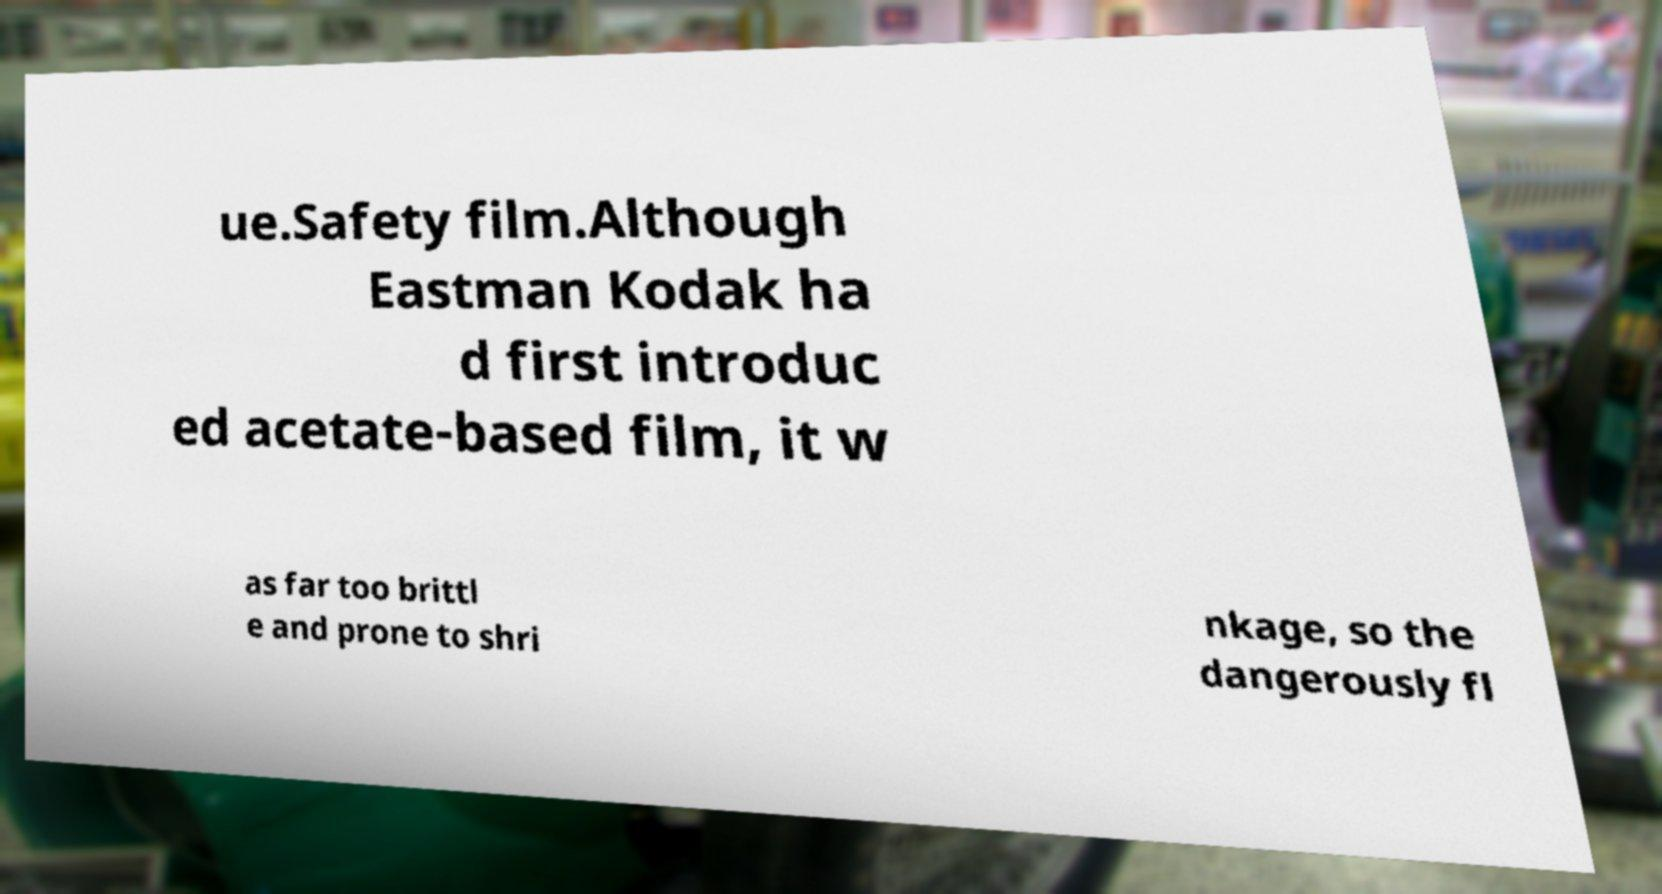Could you extract and type out the text from this image? ue.Safety film.Although Eastman Kodak ha d first introduc ed acetate-based film, it w as far too brittl e and prone to shri nkage, so the dangerously fl 